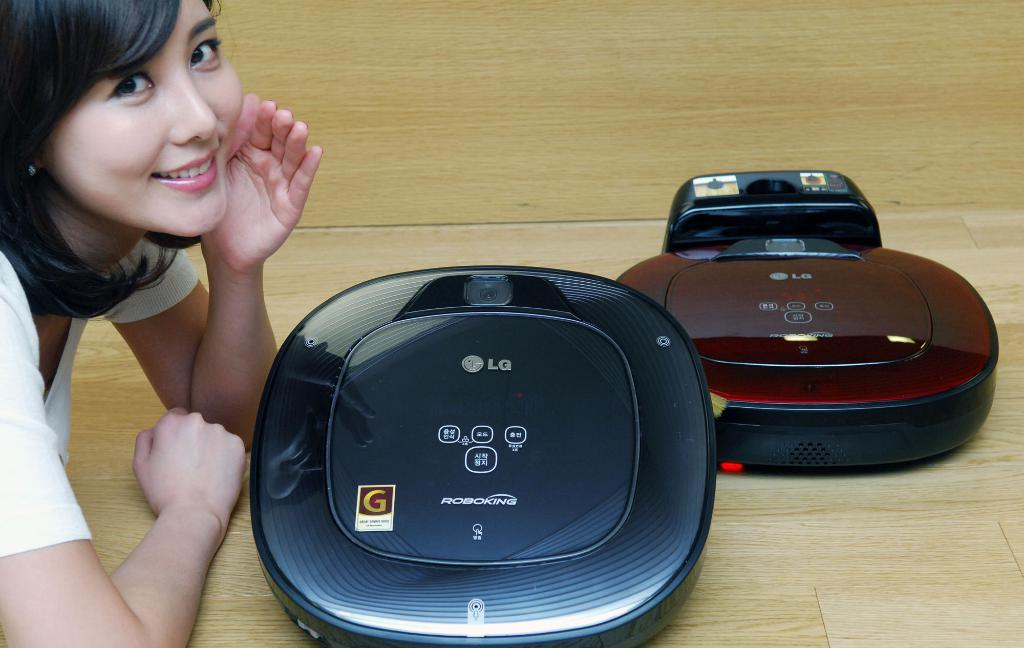<image>
Render a clear and concise summary of the photo. Two LG Robokings with a woman smiling next to them. 